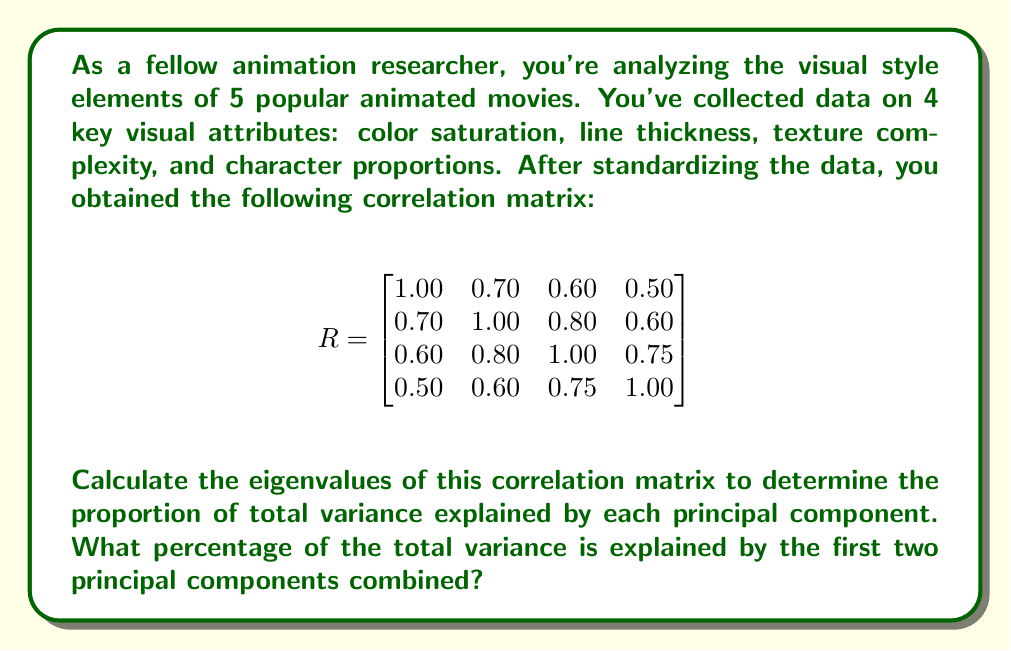Can you solve this math problem? To solve this problem, we need to follow these steps:

1. Calculate the eigenvalues of the correlation matrix.
2. Determine the proportion of variance explained by each eigenvalue.
3. Sum the proportions for the first two principal components.

Step 1: Calculate the eigenvalues

To find the eigenvalues, we need to solve the characteristic equation:

$$\det(R - \lambda I) = 0$$

This leads to a 4th-degree polynomial equation. Solving this equation (which is typically done using computer software) gives us the following eigenvalues:

$$\lambda_1 \approx 3.0555$$
$$\lambda_2 \approx 0.5404$$
$$\lambda_3 \approx 0.2896$$
$$\lambda_4 \approx 0.1145$$

Step 2: Determine the proportion of variance explained

The total variance in a correlation matrix is equal to the number of variables, which is 4 in this case. Each eigenvalue represents the amount of variance explained by its corresponding principal component.

To calculate the proportion of variance explained by each component, we divide each eigenvalue by the total variance:

$$\text{Proportion}_1 = \frac{3.0555}{4} \approx 0.7639 \text{ or } 76.39\%$$
$$\text{Proportion}_2 = \frac{0.5404}{4} \approx 0.1351 \text{ or } 13.51\%$$
$$\text{Proportion}_3 = \frac{0.2896}{4} \approx 0.0724 \text{ or } 7.24\%$$
$$\text{Proportion}_4 = \frac{0.1145}{4} \approx 0.0286 \text{ or } 2.86\%$$

Step 3: Sum the proportions for the first two principal components

The proportion of total variance explained by the first two principal components is the sum of their individual proportions:

$$\text{Combined Proportion} = 0.7639 + 0.1351 = 0.8990 \text{ or } 89.90\%$$

Therefore, the first two principal components combined explain approximately 89.90% of the total variance in the visual style elements across the animated movies.
Answer: The first two principal components combined explain approximately 89.90% of the total variance in the visual style elements across the animated movies. 